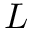Convert formula to latex. <formula><loc_0><loc_0><loc_500><loc_500>L</formula> 